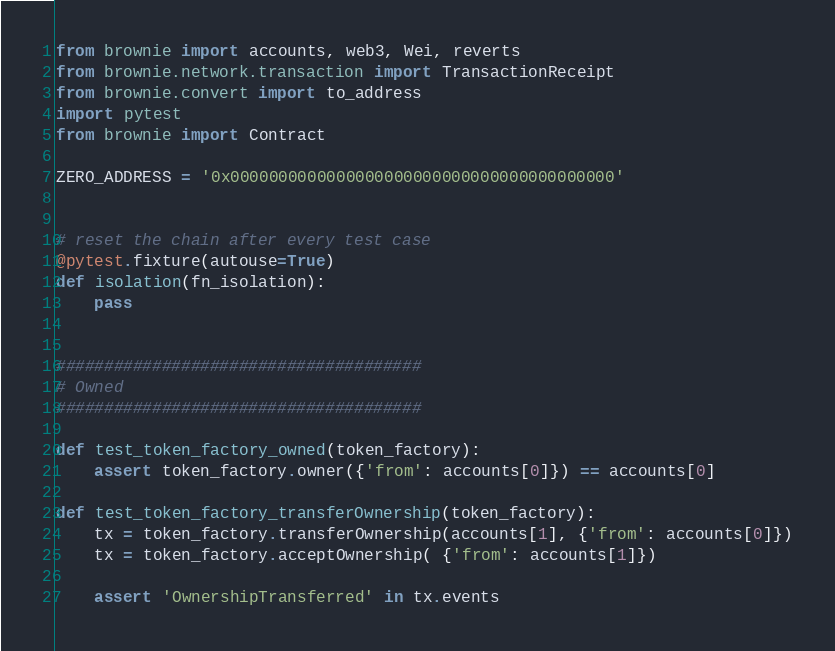Convert code to text. <code><loc_0><loc_0><loc_500><loc_500><_Python_>from brownie import accounts, web3, Wei, reverts
from brownie.network.transaction import TransactionReceipt
from brownie.convert import to_address
import pytest
from brownie import Contract

ZERO_ADDRESS = '0x0000000000000000000000000000000000000000'


# reset the chain after every test case
@pytest.fixture(autouse=True)
def isolation(fn_isolation):
    pass


######################################
# Owned
######################################

def test_token_factory_owned(token_factory):
    assert token_factory.owner({'from': accounts[0]}) == accounts[0]

def test_token_factory_transferOwnership(token_factory):
    tx = token_factory.transferOwnership(accounts[1], {'from': accounts[0]})
    tx = token_factory.acceptOwnership( {'from': accounts[1]})

    assert 'OwnershipTransferred' in tx.events</code> 